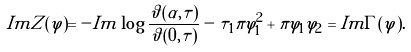Convert formula to latex. <formula><loc_0><loc_0><loc_500><loc_500>I m Z ( \varphi ) = - I m \log \frac { \vartheta ( \alpha , \tau ) } { \vartheta ( 0 , \tau ) } - \tau _ { 1 } \pi \varphi _ { 1 } ^ { 2 } + \pi \varphi _ { 1 } \varphi _ { 2 } = I m \Gamma ( \varphi ) .</formula> 